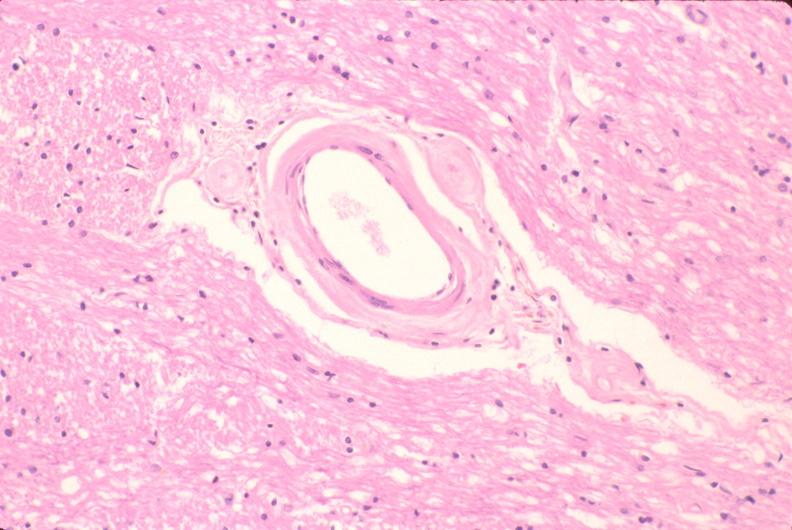s parathyroid present?
Answer the question using a single word or phrase. No 